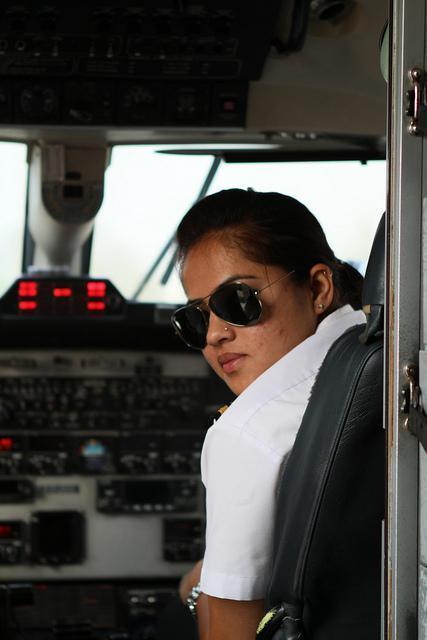How many doors does this fridge have?
Give a very brief answer. 0. 